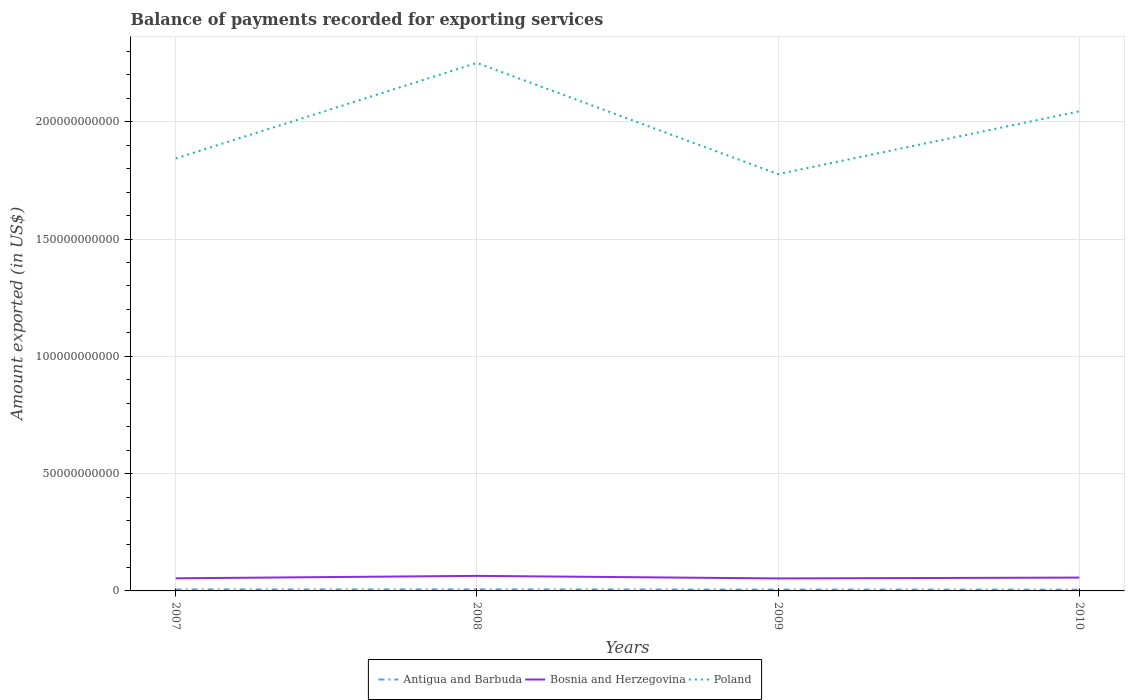Is the number of lines equal to the number of legend labels?
Give a very brief answer. Yes. Across all years, what is the maximum amount exported in Antigua and Barbuda?
Ensure brevity in your answer.  5.35e+08. What is the total amount exported in Poland in the graph?
Offer a terse response. 6.70e+09. What is the difference between the highest and the second highest amount exported in Antigua and Barbuda?
Provide a succinct answer. 1.07e+08. What is the difference between the highest and the lowest amount exported in Poland?
Keep it short and to the point. 2. Is the amount exported in Poland strictly greater than the amount exported in Bosnia and Herzegovina over the years?
Offer a very short reply. No. How many lines are there?
Ensure brevity in your answer.  3. Are the values on the major ticks of Y-axis written in scientific E-notation?
Give a very brief answer. No. Does the graph contain any zero values?
Your answer should be very brief. No. What is the title of the graph?
Your answer should be very brief. Balance of payments recorded for exporting services. What is the label or title of the Y-axis?
Your answer should be very brief. Amount exported (in US$). What is the Amount exported (in US$) of Antigua and Barbuda in 2007?
Your answer should be compact. 6.07e+08. What is the Amount exported (in US$) of Bosnia and Herzegovina in 2007?
Provide a succinct answer. 5.38e+09. What is the Amount exported (in US$) of Poland in 2007?
Give a very brief answer. 1.84e+11. What is the Amount exported (in US$) of Antigua and Barbuda in 2008?
Offer a very short reply. 6.41e+08. What is the Amount exported (in US$) in Bosnia and Herzegovina in 2008?
Give a very brief answer. 6.41e+09. What is the Amount exported (in US$) of Poland in 2008?
Offer a terse response. 2.25e+11. What is the Amount exported (in US$) in Antigua and Barbuda in 2009?
Your answer should be compact. 5.75e+08. What is the Amount exported (in US$) in Bosnia and Herzegovina in 2009?
Offer a very short reply. 5.33e+09. What is the Amount exported (in US$) of Poland in 2009?
Keep it short and to the point. 1.78e+11. What is the Amount exported (in US$) in Antigua and Barbuda in 2010?
Your answer should be compact. 5.35e+08. What is the Amount exported (in US$) in Bosnia and Herzegovina in 2010?
Your response must be concise. 5.69e+09. What is the Amount exported (in US$) of Poland in 2010?
Provide a short and direct response. 2.04e+11. Across all years, what is the maximum Amount exported (in US$) of Antigua and Barbuda?
Give a very brief answer. 6.41e+08. Across all years, what is the maximum Amount exported (in US$) of Bosnia and Herzegovina?
Give a very brief answer. 6.41e+09. Across all years, what is the maximum Amount exported (in US$) in Poland?
Your answer should be very brief. 2.25e+11. Across all years, what is the minimum Amount exported (in US$) in Antigua and Barbuda?
Offer a terse response. 5.35e+08. Across all years, what is the minimum Amount exported (in US$) in Bosnia and Herzegovina?
Provide a short and direct response. 5.33e+09. Across all years, what is the minimum Amount exported (in US$) in Poland?
Provide a short and direct response. 1.78e+11. What is the total Amount exported (in US$) in Antigua and Barbuda in the graph?
Your answer should be compact. 2.36e+09. What is the total Amount exported (in US$) in Bosnia and Herzegovina in the graph?
Your answer should be compact. 2.28e+1. What is the total Amount exported (in US$) in Poland in the graph?
Keep it short and to the point. 7.92e+11. What is the difference between the Amount exported (in US$) in Antigua and Barbuda in 2007 and that in 2008?
Provide a succinct answer. -3.44e+07. What is the difference between the Amount exported (in US$) of Bosnia and Herzegovina in 2007 and that in 2008?
Keep it short and to the point. -1.03e+09. What is the difference between the Amount exported (in US$) of Poland in 2007 and that in 2008?
Keep it short and to the point. -4.07e+1. What is the difference between the Amount exported (in US$) of Antigua and Barbuda in 2007 and that in 2009?
Offer a terse response. 3.23e+07. What is the difference between the Amount exported (in US$) in Bosnia and Herzegovina in 2007 and that in 2009?
Give a very brief answer. 5.11e+07. What is the difference between the Amount exported (in US$) of Poland in 2007 and that in 2009?
Provide a short and direct response. 6.70e+09. What is the difference between the Amount exported (in US$) of Antigua and Barbuda in 2007 and that in 2010?
Ensure brevity in your answer.  7.21e+07. What is the difference between the Amount exported (in US$) in Bosnia and Herzegovina in 2007 and that in 2010?
Your answer should be very brief. -3.12e+08. What is the difference between the Amount exported (in US$) in Poland in 2007 and that in 2010?
Your answer should be compact. -2.01e+1. What is the difference between the Amount exported (in US$) in Antigua and Barbuda in 2008 and that in 2009?
Your response must be concise. 6.67e+07. What is the difference between the Amount exported (in US$) of Bosnia and Herzegovina in 2008 and that in 2009?
Provide a short and direct response. 1.08e+09. What is the difference between the Amount exported (in US$) of Poland in 2008 and that in 2009?
Give a very brief answer. 4.74e+1. What is the difference between the Amount exported (in US$) of Antigua and Barbuda in 2008 and that in 2010?
Your response must be concise. 1.07e+08. What is the difference between the Amount exported (in US$) in Bosnia and Herzegovina in 2008 and that in 2010?
Your response must be concise. 7.21e+08. What is the difference between the Amount exported (in US$) of Poland in 2008 and that in 2010?
Provide a succinct answer. 2.06e+1. What is the difference between the Amount exported (in US$) in Antigua and Barbuda in 2009 and that in 2010?
Offer a terse response. 3.98e+07. What is the difference between the Amount exported (in US$) of Bosnia and Herzegovina in 2009 and that in 2010?
Keep it short and to the point. -3.63e+08. What is the difference between the Amount exported (in US$) of Poland in 2009 and that in 2010?
Offer a terse response. -2.68e+1. What is the difference between the Amount exported (in US$) of Antigua and Barbuda in 2007 and the Amount exported (in US$) of Bosnia and Herzegovina in 2008?
Your response must be concise. -5.81e+09. What is the difference between the Amount exported (in US$) in Antigua and Barbuda in 2007 and the Amount exported (in US$) in Poland in 2008?
Offer a very short reply. -2.24e+11. What is the difference between the Amount exported (in US$) in Bosnia and Herzegovina in 2007 and the Amount exported (in US$) in Poland in 2008?
Provide a succinct answer. -2.20e+11. What is the difference between the Amount exported (in US$) of Antigua and Barbuda in 2007 and the Amount exported (in US$) of Bosnia and Herzegovina in 2009?
Make the answer very short. -4.72e+09. What is the difference between the Amount exported (in US$) of Antigua and Barbuda in 2007 and the Amount exported (in US$) of Poland in 2009?
Your answer should be very brief. -1.77e+11. What is the difference between the Amount exported (in US$) in Bosnia and Herzegovina in 2007 and the Amount exported (in US$) in Poland in 2009?
Ensure brevity in your answer.  -1.72e+11. What is the difference between the Amount exported (in US$) in Antigua and Barbuda in 2007 and the Amount exported (in US$) in Bosnia and Herzegovina in 2010?
Your answer should be compact. -5.08e+09. What is the difference between the Amount exported (in US$) of Antigua and Barbuda in 2007 and the Amount exported (in US$) of Poland in 2010?
Keep it short and to the point. -2.04e+11. What is the difference between the Amount exported (in US$) in Bosnia and Herzegovina in 2007 and the Amount exported (in US$) in Poland in 2010?
Make the answer very short. -1.99e+11. What is the difference between the Amount exported (in US$) in Antigua and Barbuda in 2008 and the Amount exported (in US$) in Bosnia and Herzegovina in 2009?
Give a very brief answer. -4.69e+09. What is the difference between the Amount exported (in US$) of Antigua and Barbuda in 2008 and the Amount exported (in US$) of Poland in 2009?
Offer a very short reply. -1.77e+11. What is the difference between the Amount exported (in US$) of Bosnia and Herzegovina in 2008 and the Amount exported (in US$) of Poland in 2009?
Provide a short and direct response. -1.71e+11. What is the difference between the Amount exported (in US$) of Antigua and Barbuda in 2008 and the Amount exported (in US$) of Bosnia and Herzegovina in 2010?
Keep it short and to the point. -5.05e+09. What is the difference between the Amount exported (in US$) of Antigua and Barbuda in 2008 and the Amount exported (in US$) of Poland in 2010?
Ensure brevity in your answer.  -2.04e+11. What is the difference between the Amount exported (in US$) in Bosnia and Herzegovina in 2008 and the Amount exported (in US$) in Poland in 2010?
Provide a short and direct response. -1.98e+11. What is the difference between the Amount exported (in US$) of Antigua and Barbuda in 2009 and the Amount exported (in US$) of Bosnia and Herzegovina in 2010?
Provide a succinct answer. -5.12e+09. What is the difference between the Amount exported (in US$) of Antigua and Barbuda in 2009 and the Amount exported (in US$) of Poland in 2010?
Make the answer very short. -2.04e+11. What is the difference between the Amount exported (in US$) in Bosnia and Herzegovina in 2009 and the Amount exported (in US$) in Poland in 2010?
Offer a very short reply. -1.99e+11. What is the average Amount exported (in US$) in Antigua and Barbuda per year?
Give a very brief answer. 5.90e+08. What is the average Amount exported (in US$) in Bosnia and Herzegovina per year?
Ensure brevity in your answer.  5.70e+09. What is the average Amount exported (in US$) in Poland per year?
Give a very brief answer. 1.98e+11. In the year 2007, what is the difference between the Amount exported (in US$) of Antigua and Barbuda and Amount exported (in US$) of Bosnia and Herzegovina?
Your answer should be very brief. -4.77e+09. In the year 2007, what is the difference between the Amount exported (in US$) of Antigua and Barbuda and Amount exported (in US$) of Poland?
Give a very brief answer. -1.84e+11. In the year 2007, what is the difference between the Amount exported (in US$) of Bosnia and Herzegovina and Amount exported (in US$) of Poland?
Offer a terse response. -1.79e+11. In the year 2008, what is the difference between the Amount exported (in US$) in Antigua and Barbuda and Amount exported (in US$) in Bosnia and Herzegovina?
Ensure brevity in your answer.  -5.77e+09. In the year 2008, what is the difference between the Amount exported (in US$) of Antigua and Barbuda and Amount exported (in US$) of Poland?
Your answer should be very brief. -2.24e+11. In the year 2008, what is the difference between the Amount exported (in US$) in Bosnia and Herzegovina and Amount exported (in US$) in Poland?
Provide a short and direct response. -2.19e+11. In the year 2009, what is the difference between the Amount exported (in US$) in Antigua and Barbuda and Amount exported (in US$) in Bosnia and Herzegovina?
Provide a succinct answer. -4.75e+09. In the year 2009, what is the difference between the Amount exported (in US$) of Antigua and Barbuda and Amount exported (in US$) of Poland?
Provide a succinct answer. -1.77e+11. In the year 2009, what is the difference between the Amount exported (in US$) in Bosnia and Herzegovina and Amount exported (in US$) in Poland?
Make the answer very short. -1.72e+11. In the year 2010, what is the difference between the Amount exported (in US$) in Antigua and Barbuda and Amount exported (in US$) in Bosnia and Herzegovina?
Offer a terse response. -5.16e+09. In the year 2010, what is the difference between the Amount exported (in US$) of Antigua and Barbuda and Amount exported (in US$) of Poland?
Ensure brevity in your answer.  -2.04e+11. In the year 2010, what is the difference between the Amount exported (in US$) of Bosnia and Herzegovina and Amount exported (in US$) of Poland?
Offer a very short reply. -1.99e+11. What is the ratio of the Amount exported (in US$) of Antigua and Barbuda in 2007 to that in 2008?
Your response must be concise. 0.95. What is the ratio of the Amount exported (in US$) of Bosnia and Herzegovina in 2007 to that in 2008?
Offer a terse response. 0.84. What is the ratio of the Amount exported (in US$) of Poland in 2007 to that in 2008?
Keep it short and to the point. 0.82. What is the ratio of the Amount exported (in US$) of Antigua and Barbuda in 2007 to that in 2009?
Offer a terse response. 1.06. What is the ratio of the Amount exported (in US$) of Bosnia and Herzegovina in 2007 to that in 2009?
Give a very brief answer. 1.01. What is the ratio of the Amount exported (in US$) of Poland in 2007 to that in 2009?
Keep it short and to the point. 1.04. What is the ratio of the Amount exported (in US$) in Antigua and Barbuda in 2007 to that in 2010?
Provide a succinct answer. 1.13. What is the ratio of the Amount exported (in US$) in Bosnia and Herzegovina in 2007 to that in 2010?
Provide a short and direct response. 0.95. What is the ratio of the Amount exported (in US$) in Poland in 2007 to that in 2010?
Provide a short and direct response. 0.9. What is the ratio of the Amount exported (in US$) in Antigua and Barbuda in 2008 to that in 2009?
Your response must be concise. 1.12. What is the ratio of the Amount exported (in US$) of Bosnia and Herzegovina in 2008 to that in 2009?
Provide a succinct answer. 1.2. What is the ratio of the Amount exported (in US$) in Poland in 2008 to that in 2009?
Your answer should be compact. 1.27. What is the ratio of the Amount exported (in US$) of Antigua and Barbuda in 2008 to that in 2010?
Your answer should be very brief. 1.2. What is the ratio of the Amount exported (in US$) in Bosnia and Herzegovina in 2008 to that in 2010?
Provide a succinct answer. 1.13. What is the ratio of the Amount exported (in US$) of Poland in 2008 to that in 2010?
Your response must be concise. 1.1. What is the ratio of the Amount exported (in US$) of Antigua and Barbuda in 2009 to that in 2010?
Your response must be concise. 1.07. What is the ratio of the Amount exported (in US$) of Bosnia and Herzegovina in 2009 to that in 2010?
Offer a terse response. 0.94. What is the ratio of the Amount exported (in US$) in Poland in 2009 to that in 2010?
Your answer should be compact. 0.87. What is the difference between the highest and the second highest Amount exported (in US$) in Antigua and Barbuda?
Offer a terse response. 3.44e+07. What is the difference between the highest and the second highest Amount exported (in US$) of Bosnia and Herzegovina?
Keep it short and to the point. 7.21e+08. What is the difference between the highest and the second highest Amount exported (in US$) in Poland?
Provide a short and direct response. 2.06e+1. What is the difference between the highest and the lowest Amount exported (in US$) in Antigua and Barbuda?
Provide a succinct answer. 1.07e+08. What is the difference between the highest and the lowest Amount exported (in US$) of Bosnia and Herzegovina?
Your response must be concise. 1.08e+09. What is the difference between the highest and the lowest Amount exported (in US$) of Poland?
Offer a terse response. 4.74e+1. 